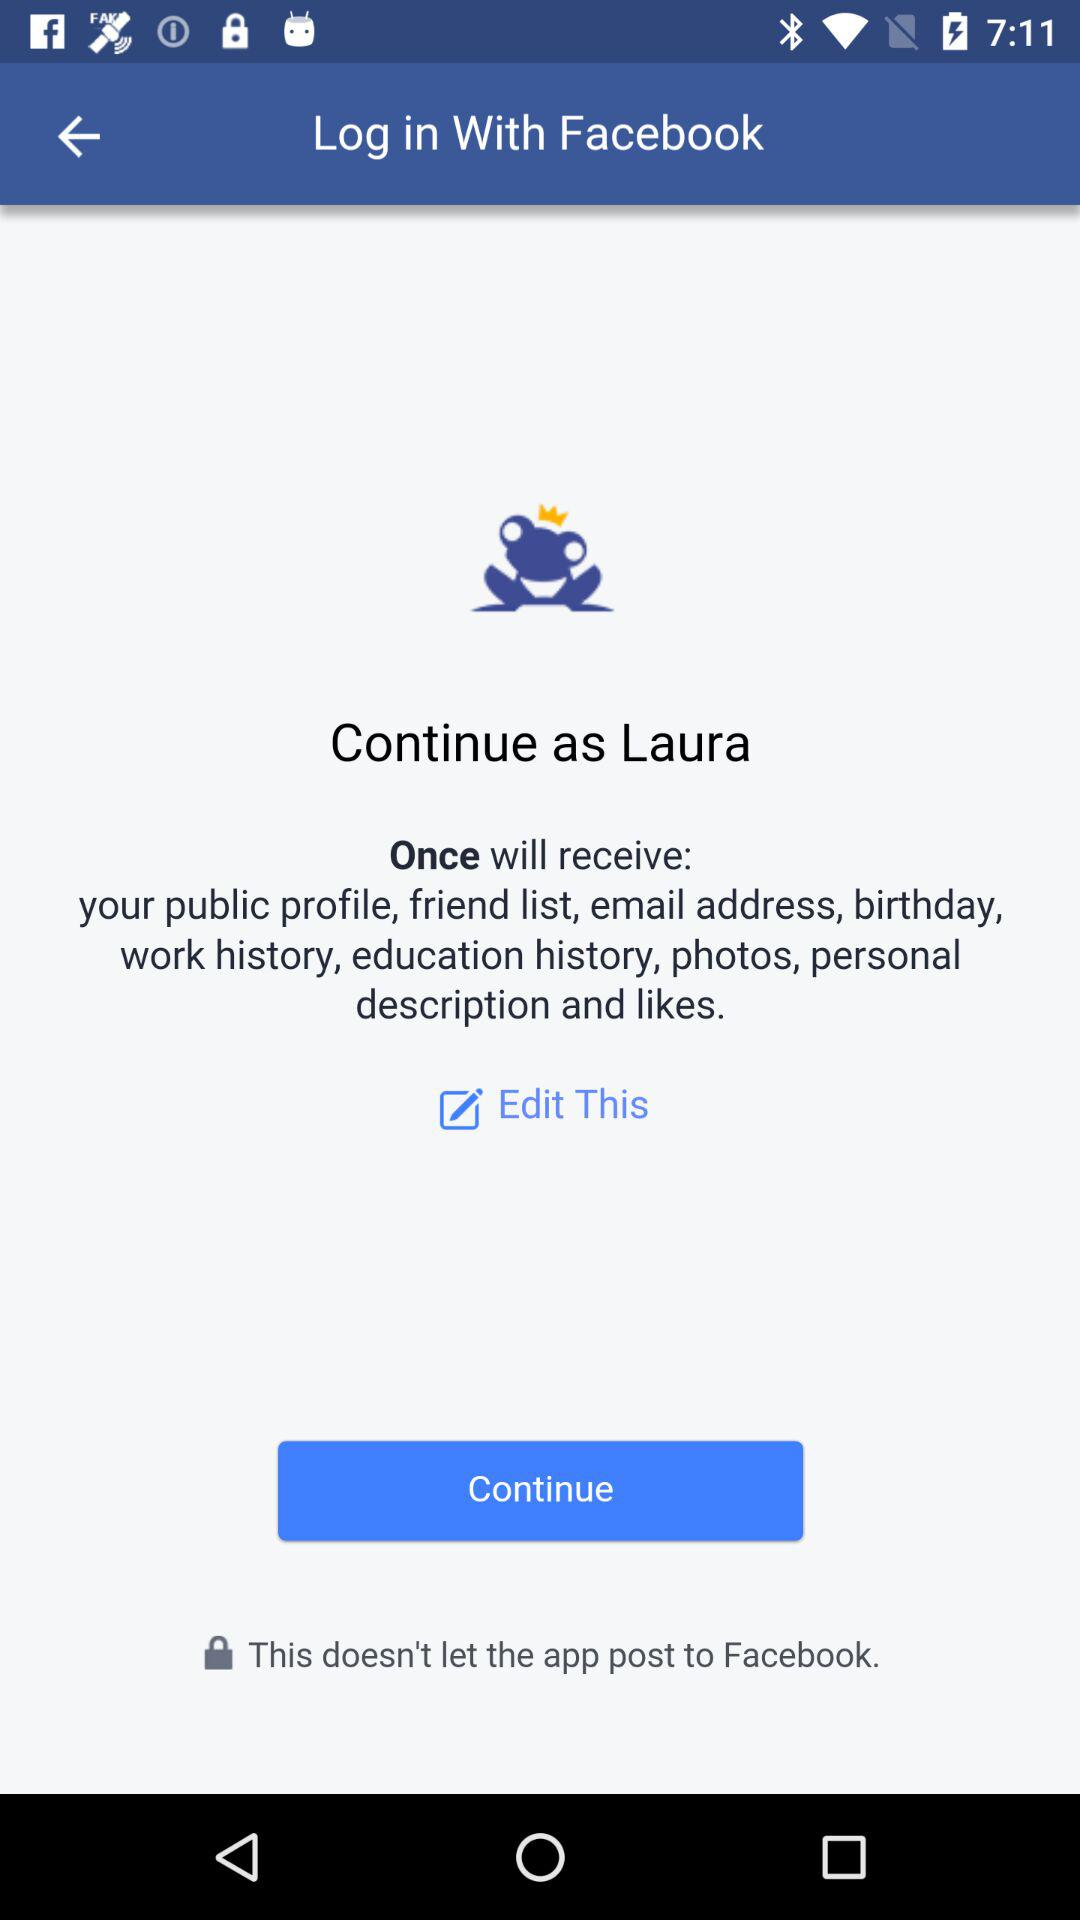What is the user name? The user name is Laura. 